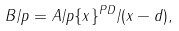Convert formula to latex. <formula><loc_0><loc_0><loc_500><loc_500>B / p = A / p \{ x \} ^ { P D } / ( x - d ) ,</formula> 